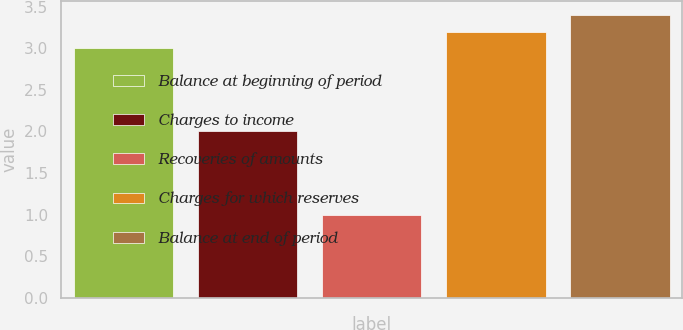Convert chart. <chart><loc_0><loc_0><loc_500><loc_500><bar_chart><fcel>Balance at beginning of period<fcel>Charges to income<fcel>Recoveries of amounts<fcel>Charges for which reserves<fcel>Balance at end of period<nl><fcel>3<fcel>2<fcel>1<fcel>3.2<fcel>3.4<nl></chart> 